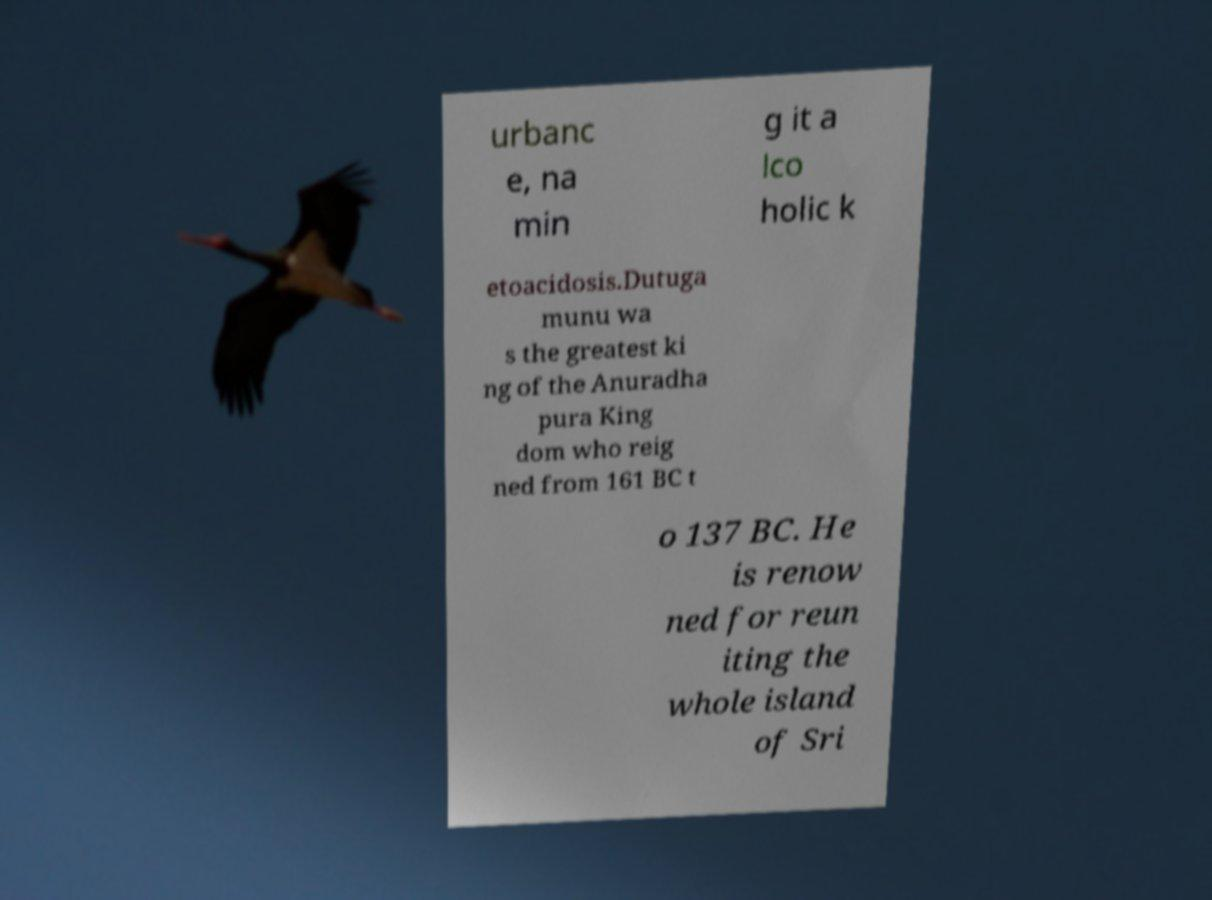I need the written content from this picture converted into text. Can you do that? urbanc e, na min g it a lco holic k etoacidosis.Dutuga munu wa s the greatest ki ng of the Anuradha pura King dom who reig ned from 161 BC t o 137 BC. He is renow ned for reun iting the whole island of Sri 